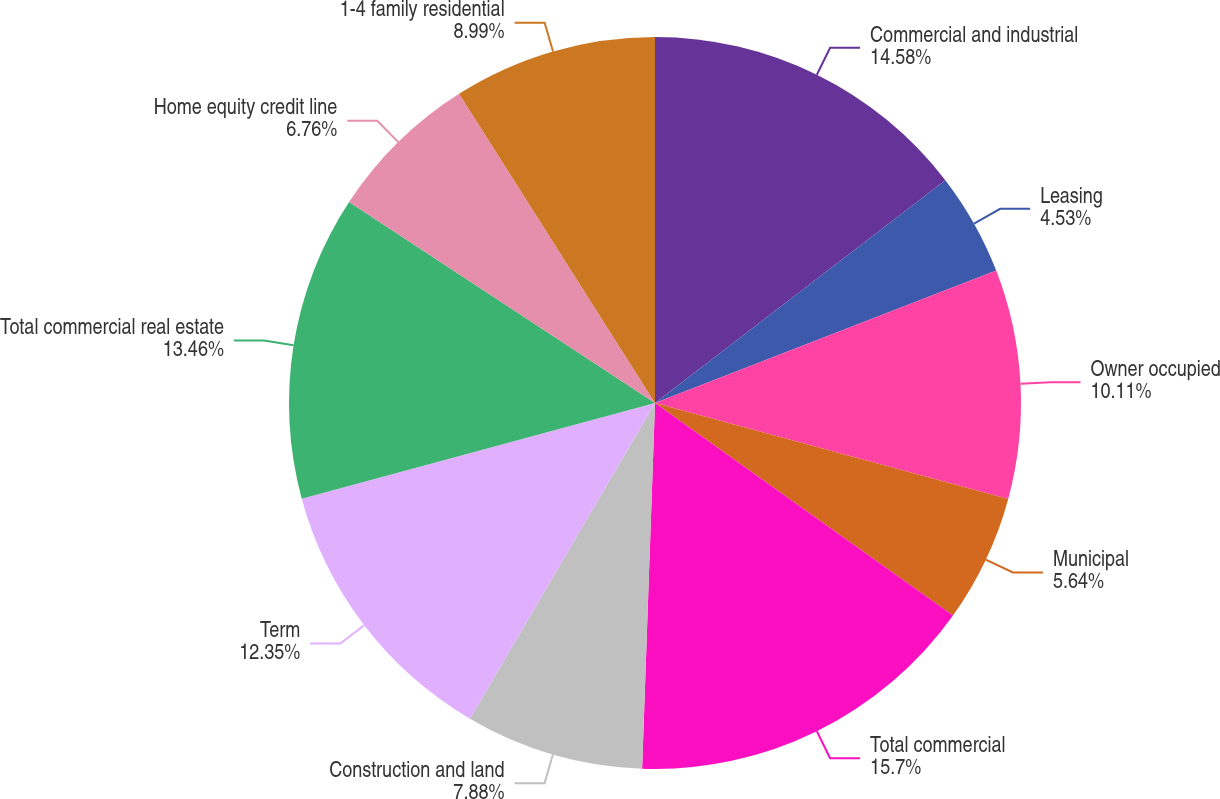<chart> <loc_0><loc_0><loc_500><loc_500><pie_chart><fcel>Commercial and industrial<fcel>Leasing<fcel>Owner occupied<fcel>Municipal<fcel>Total commercial<fcel>Construction and land<fcel>Term<fcel>Total commercial real estate<fcel>Home equity credit line<fcel>1-4 family residential<nl><fcel>14.58%<fcel>4.53%<fcel>10.11%<fcel>5.64%<fcel>15.7%<fcel>7.88%<fcel>12.35%<fcel>13.46%<fcel>6.76%<fcel>8.99%<nl></chart> 